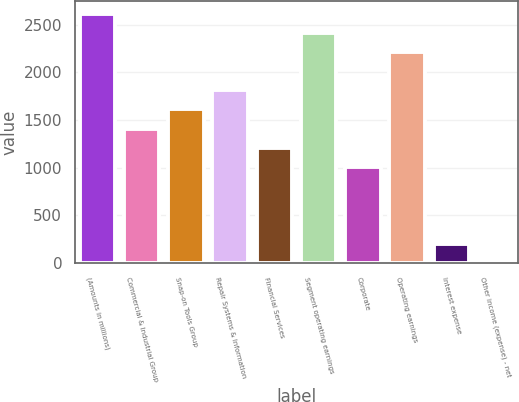<chart> <loc_0><loc_0><loc_500><loc_500><bar_chart><fcel>(Amounts in millions)<fcel>Commercial & Industrial Group<fcel>Snap-on Tools Group<fcel>Repair Systems & Information<fcel>Financial Services<fcel>Segment operating earnings<fcel>Corporate<fcel>Operating earnings<fcel>Interest expense<fcel>Other income (expense) - net<nl><fcel>2615.73<fcel>1410.27<fcel>1611.18<fcel>1812.09<fcel>1209.36<fcel>2414.82<fcel>1008.45<fcel>2213.91<fcel>204.81<fcel>3.9<nl></chart> 